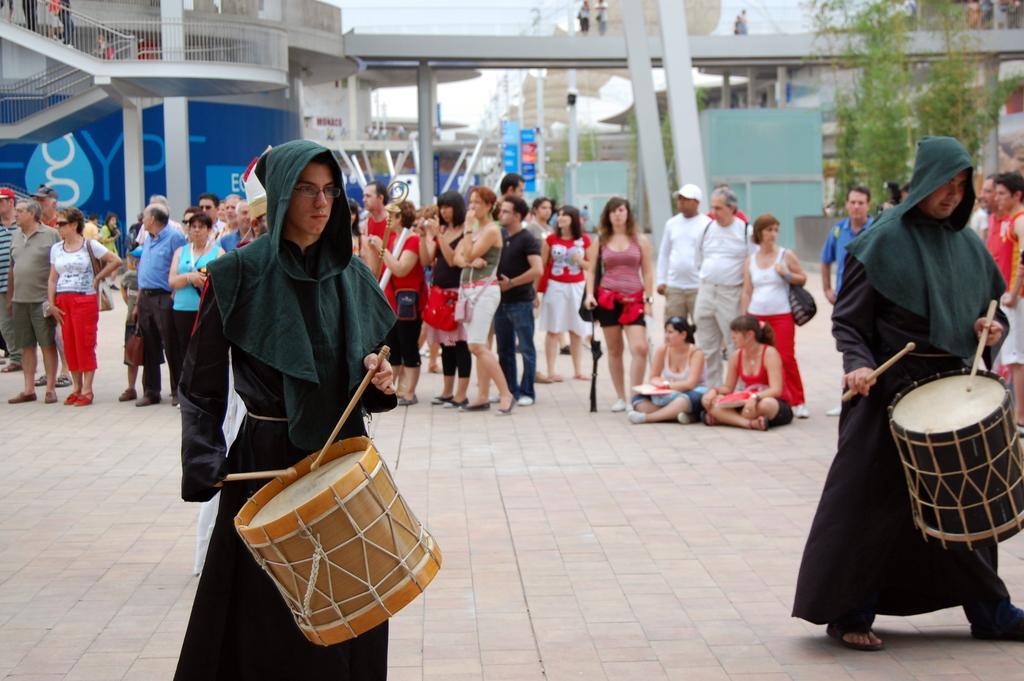Please provide a concise description of this image. A place where there are group of people standing and some people siting on the floor and two guys are playing a musical instrument wearing the same dress. 